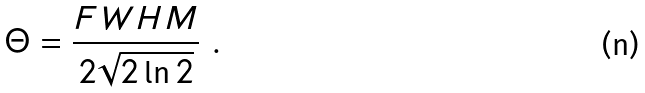<formula> <loc_0><loc_0><loc_500><loc_500>\Theta = \frac { F W H M } { 2 \sqrt { 2 \ln { 2 } } } \ .</formula> 